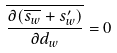<formula> <loc_0><loc_0><loc_500><loc_500>\overline { \frac { \partial ( \overline { s _ { w } } + s _ { w } ^ { \prime } ) } { \partial d _ { w } } } = 0</formula> 